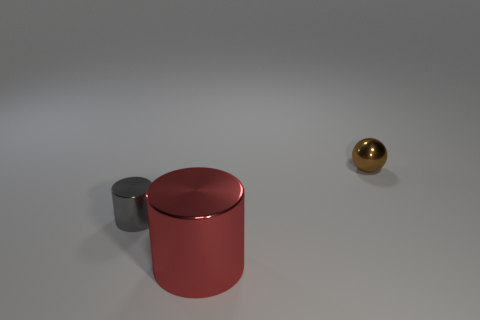Add 1 yellow rubber spheres. How many objects exist? 4 Subtract all cylinders. How many objects are left? 1 Add 3 gray metal things. How many gray metal things are left? 4 Add 3 cyan cylinders. How many cyan cylinders exist? 3 Subtract 0 red balls. How many objects are left? 3 Subtract all tiny cyan metallic cylinders. Subtract all red cylinders. How many objects are left? 2 